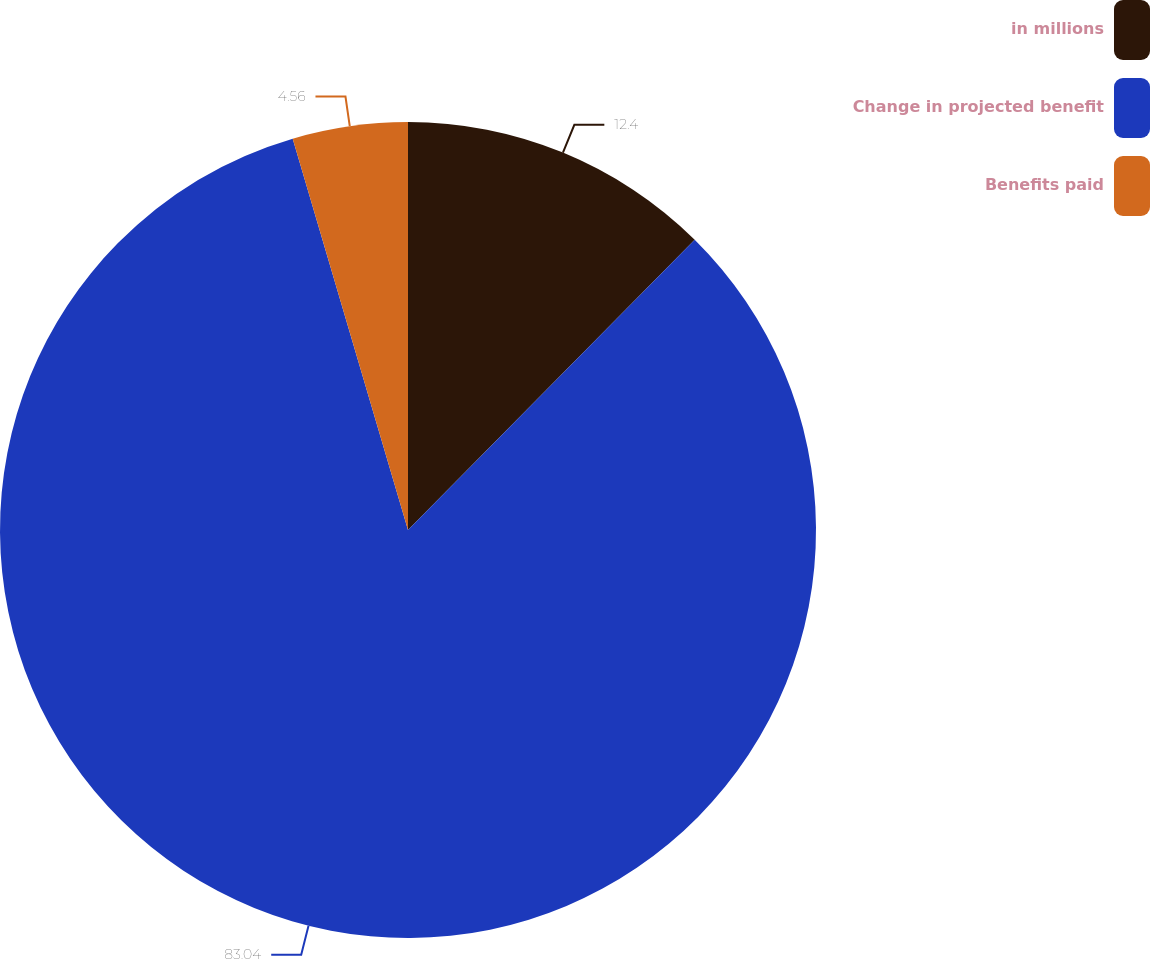Convert chart to OTSL. <chart><loc_0><loc_0><loc_500><loc_500><pie_chart><fcel>in millions<fcel>Change in projected benefit<fcel>Benefits paid<nl><fcel>12.4%<fcel>83.04%<fcel>4.56%<nl></chart> 